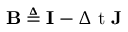<formula> <loc_0><loc_0><loc_500><loc_500>B \triangle q I - { \Delta t } J</formula> 